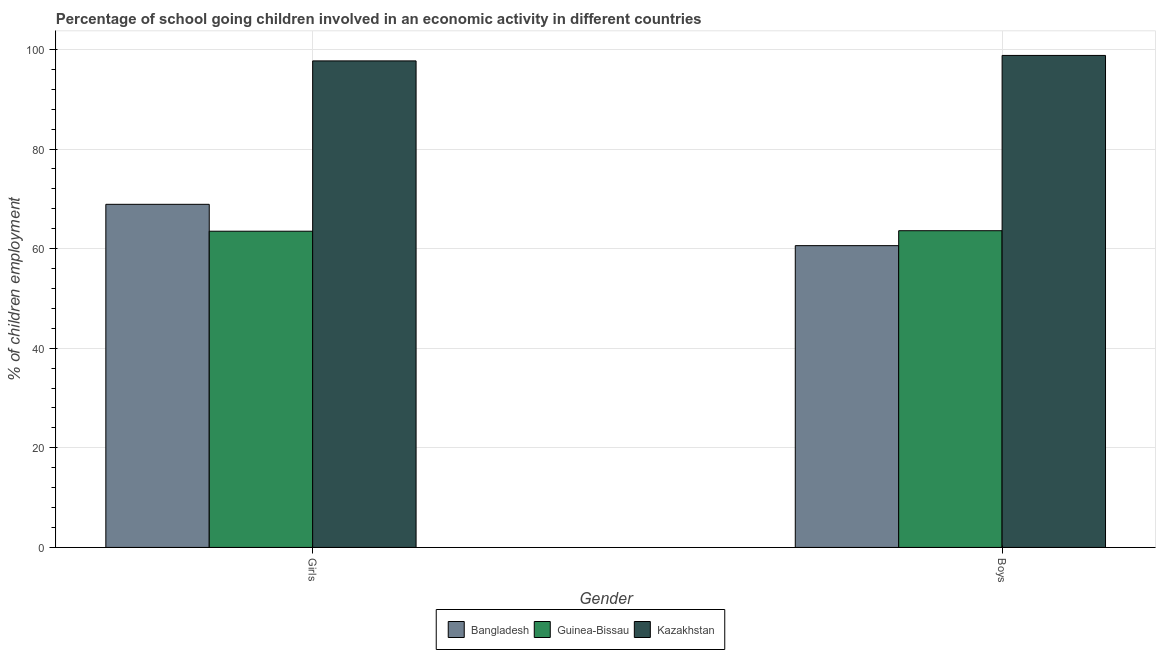How many different coloured bars are there?
Provide a succinct answer. 3. Are the number of bars per tick equal to the number of legend labels?
Ensure brevity in your answer.  Yes. Are the number of bars on each tick of the X-axis equal?
Keep it short and to the point. Yes. How many bars are there on the 1st tick from the left?
Your answer should be very brief. 3. How many bars are there on the 2nd tick from the right?
Make the answer very short. 3. What is the label of the 1st group of bars from the left?
Provide a short and direct response. Girls. What is the percentage of school going girls in Guinea-Bissau?
Give a very brief answer. 63.5. Across all countries, what is the maximum percentage of school going boys?
Offer a terse response. 98.8. Across all countries, what is the minimum percentage of school going boys?
Your answer should be very brief. 60.6. In which country was the percentage of school going boys maximum?
Provide a succinct answer. Kazakhstan. In which country was the percentage of school going boys minimum?
Ensure brevity in your answer.  Bangladesh. What is the total percentage of school going boys in the graph?
Ensure brevity in your answer.  223. What is the difference between the percentage of school going boys in Bangladesh and that in Kazakhstan?
Give a very brief answer. -38.2. What is the difference between the percentage of school going boys in Kazakhstan and the percentage of school going girls in Guinea-Bissau?
Your answer should be very brief. 35.3. What is the average percentage of school going boys per country?
Provide a short and direct response. 74.33. What is the difference between the percentage of school going girls and percentage of school going boys in Guinea-Bissau?
Provide a short and direct response. -0.1. In how many countries, is the percentage of school going girls greater than 76 %?
Provide a short and direct response. 1. What is the ratio of the percentage of school going girls in Guinea-Bissau to that in Bangladesh?
Offer a terse response. 0.92. Is the percentage of school going girls in Guinea-Bissau less than that in Kazakhstan?
Make the answer very short. Yes. In how many countries, is the percentage of school going boys greater than the average percentage of school going boys taken over all countries?
Give a very brief answer. 1. What does the 1st bar from the right in Girls represents?
Your response must be concise. Kazakhstan. How many countries are there in the graph?
Ensure brevity in your answer.  3. What is the difference between two consecutive major ticks on the Y-axis?
Keep it short and to the point. 20. Are the values on the major ticks of Y-axis written in scientific E-notation?
Keep it short and to the point. No. Does the graph contain any zero values?
Your response must be concise. No. Where does the legend appear in the graph?
Make the answer very short. Bottom center. What is the title of the graph?
Keep it short and to the point. Percentage of school going children involved in an economic activity in different countries. What is the label or title of the Y-axis?
Keep it short and to the point. % of children employment. What is the % of children employment in Bangladesh in Girls?
Keep it short and to the point. 68.9. What is the % of children employment in Guinea-Bissau in Girls?
Your response must be concise. 63.5. What is the % of children employment in Kazakhstan in Girls?
Give a very brief answer. 97.7. What is the % of children employment in Bangladesh in Boys?
Your answer should be compact. 60.6. What is the % of children employment in Guinea-Bissau in Boys?
Keep it short and to the point. 63.6. What is the % of children employment of Kazakhstan in Boys?
Provide a succinct answer. 98.8. Across all Gender, what is the maximum % of children employment in Bangladesh?
Ensure brevity in your answer.  68.9. Across all Gender, what is the maximum % of children employment in Guinea-Bissau?
Give a very brief answer. 63.6. Across all Gender, what is the maximum % of children employment of Kazakhstan?
Your response must be concise. 98.8. Across all Gender, what is the minimum % of children employment in Bangladesh?
Your answer should be very brief. 60.6. Across all Gender, what is the minimum % of children employment in Guinea-Bissau?
Offer a very short reply. 63.5. Across all Gender, what is the minimum % of children employment in Kazakhstan?
Your response must be concise. 97.7. What is the total % of children employment of Bangladesh in the graph?
Your answer should be compact. 129.5. What is the total % of children employment in Guinea-Bissau in the graph?
Make the answer very short. 127.1. What is the total % of children employment of Kazakhstan in the graph?
Keep it short and to the point. 196.5. What is the difference between the % of children employment in Bangladesh in Girls and that in Boys?
Give a very brief answer. 8.3. What is the difference between the % of children employment of Bangladesh in Girls and the % of children employment of Guinea-Bissau in Boys?
Your response must be concise. 5.3. What is the difference between the % of children employment in Bangladesh in Girls and the % of children employment in Kazakhstan in Boys?
Your answer should be very brief. -29.9. What is the difference between the % of children employment in Guinea-Bissau in Girls and the % of children employment in Kazakhstan in Boys?
Your answer should be very brief. -35.3. What is the average % of children employment in Bangladesh per Gender?
Make the answer very short. 64.75. What is the average % of children employment in Guinea-Bissau per Gender?
Provide a succinct answer. 63.55. What is the average % of children employment of Kazakhstan per Gender?
Provide a succinct answer. 98.25. What is the difference between the % of children employment of Bangladesh and % of children employment of Guinea-Bissau in Girls?
Ensure brevity in your answer.  5.4. What is the difference between the % of children employment of Bangladesh and % of children employment of Kazakhstan in Girls?
Your response must be concise. -28.8. What is the difference between the % of children employment of Guinea-Bissau and % of children employment of Kazakhstan in Girls?
Provide a short and direct response. -34.2. What is the difference between the % of children employment of Bangladesh and % of children employment of Guinea-Bissau in Boys?
Give a very brief answer. -3. What is the difference between the % of children employment in Bangladesh and % of children employment in Kazakhstan in Boys?
Give a very brief answer. -38.2. What is the difference between the % of children employment of Guinea-Bissau and % of children employment of Kazakhstan in Boys?
Ensure brevity in your answer.  -35.2. What is the ratio of the % of children employment in Bangladesh in Girls to that in Boys?
Your response must be concise. 1.14. What is the ratio of the % of children employment of Guinea-Bissau in Girls to that in Boys?
Your answer should be very brief. 1. What is the ratio of the % of children employment of Kazakhstan in Girls to that in Boys?
Offer a very short reply. 0.99. What is the difference between the highest and the second highest % of children employment of Kazakhstan?
Your answer should be compact. 1.1. What is the difference between the highest and the lowest % of children employment in Bangladesh?
Give a very brief answer. 8.3. 